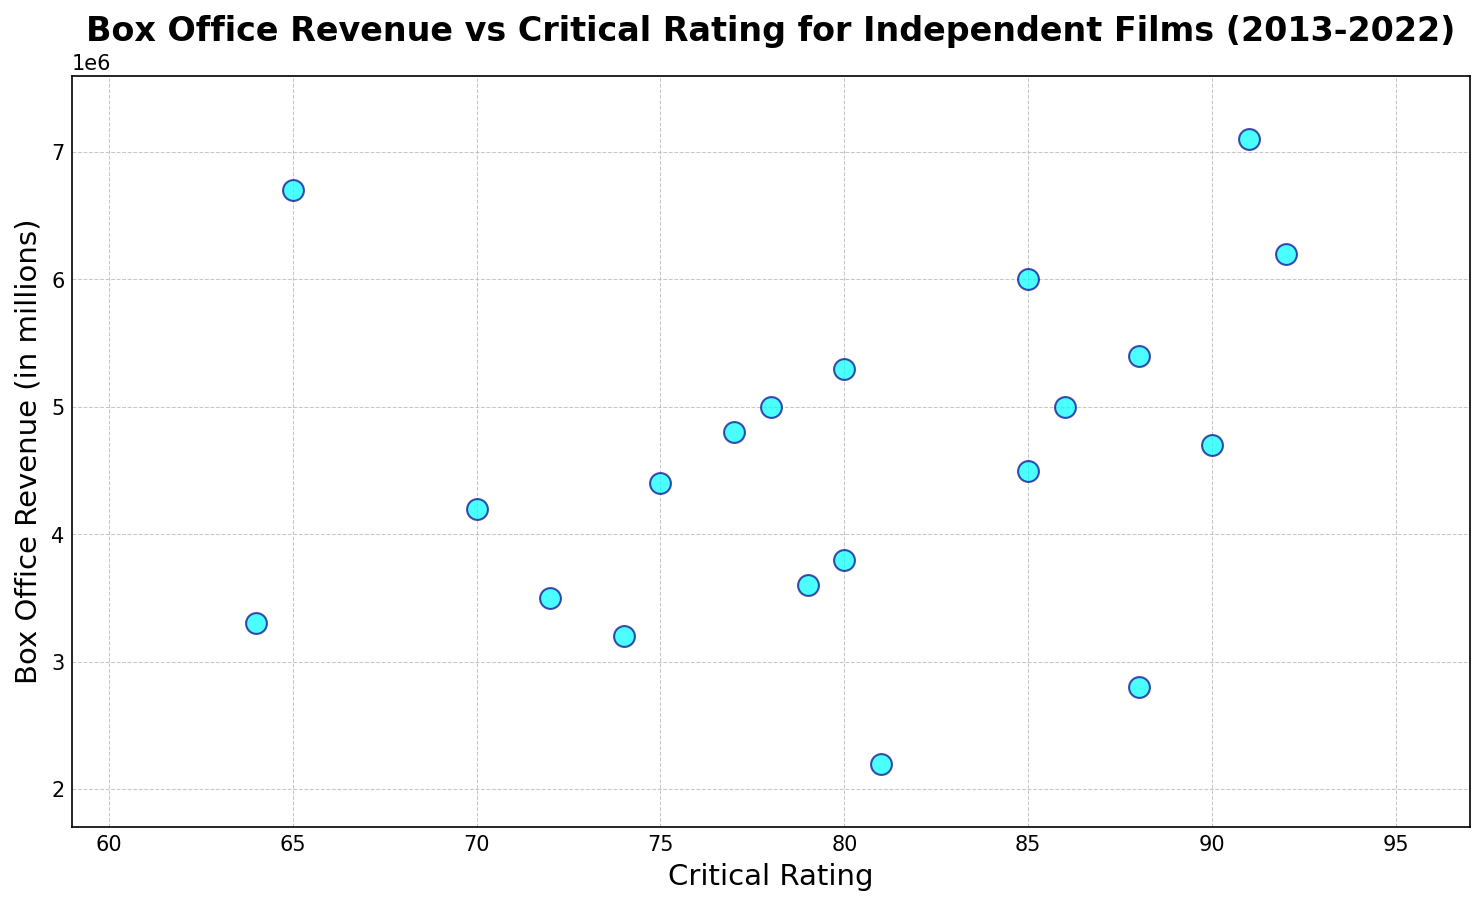What's the relationship between critical rating and box office revenue for films with the highest critical ratings? Identify the films with the highest critical ratings (above 90) and observe their box office revenues. The films "Film M" and "Film O" have high critical ratings of 91 and 92, respectively. Both also have high box office revenues of 7.1 million and 6.2 million. Visual inspection shows that higher critical ratings generally correspond to higher box office revenues in this subset.
Answer: Higher critical ratings generally correspond to higher box office revenues Which year saw the highest box office revenue film, and what was its critical rating? Observe the data points to find the film with the highest box office revenue and check its corresponding year and critical rating. "Film M" released in 2019 has the highest box office revenue of 7.1 million and a critical rating of 91.
Answer: 2019, 91 How does the box office revenue of films with critical ratings between 70 and 80 compare to those above 80? Identify the films within the rating range of 70-80 and above 80. Calculate the average box office revenue for each group. Films within 70-80: "Film B", "Film D", "Film H", "Film N", "Film P", "Film R", "Film T" with revenues summing up to 30400000 for 7 films (average: 4.343 million). Films above 80: "Film A", "Film C", "Film E", "Film F", "Film G", "Film I", "Film J", "Film K", "Film L", "Film M", "Film O", "Film Q", "Film S" with revenues summing up to 63900000 for 13 films (average: 4.915 million). Films with ratings above 80 earn more on average.
Answer: Above 80 earn more on average Is there any film with a critical rating below 70 and what is its box office revenue? Check the critical ratings to see if any film has a rating below 70 and identify the corresponding box office revenue. "Film D" has a critical rating of 65 with a box office revenue of 6.7 million, and "Film L" has a critical rating of 64 and a box office revenue of 3.3 million.
Answer: Yes, 6.7 million and 3.3 million Which film had the highest box office revenue in 2021, and what was its critical rating? Locate the data points for the year 2021 and find the film with the highest box office revenue and its critical rating. "Film Q" had the highest revenue in 2021 with 5.4 million and a critical rating of 88.
Answer: Film Q, 88 What is the most common critical rating range (e.g., 70-80, 80-90) among all films, and what is the average box office revenue in that range? Categorize the films by critical rating ranges and count the number of films in each range. Then, find the range with the highest count and calculate the average box office revenue for that range. The range 80-90 has the most films (7 films: "Film A", "Film C", "Film E", "Film F", "Film G", "Film I", and "Film J"). Their total revenue is 29800000 for 7 films, averaging 4.257 million.
Answer: 80-90, 4.257 million 